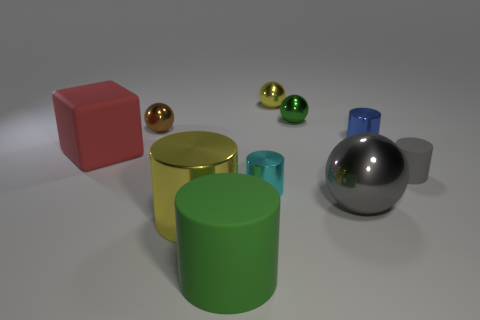Do the small cyan shiny object and the large green object have the same shape? Yes, both the small cyan object, which appears to be reflective and resembles a marble, and the large green object, a cylindrical container, share a cylindrical shape. Their cylindrical nature is evidenced by their circular bases and straight sides, a common characteristic of cylinders. 